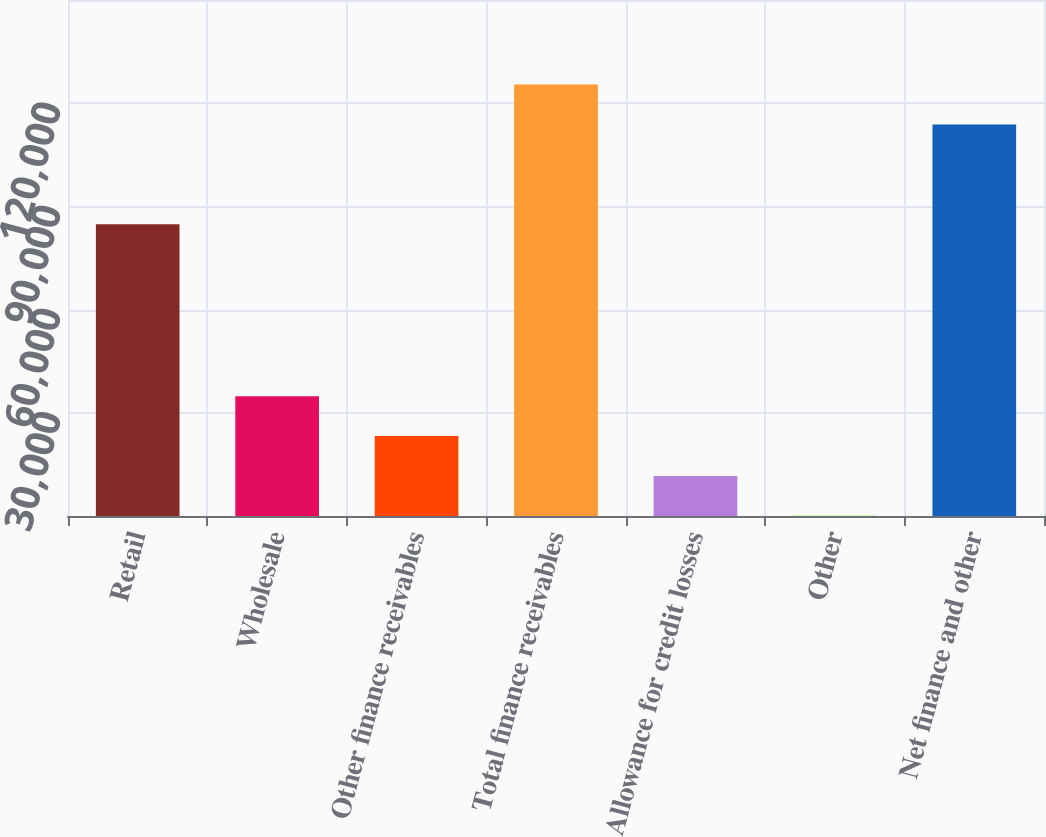Convert chart to OTSL. <chart><loc_0><loc_0><loc_500><loc_500><bar_chart><fcel>Retail<fcel>Wholesale<fcel>Other finance receivables<fcel>Total finance receivables<fcel>Allowance for credit losses<fcel>Other<fcel>Net finance and other<nl><fcel>84843<fcel>34825.8<fcel>23241.2<fcel>125409<fcel>11656.6<fcel>72<fcel>113824<nl></chart> 